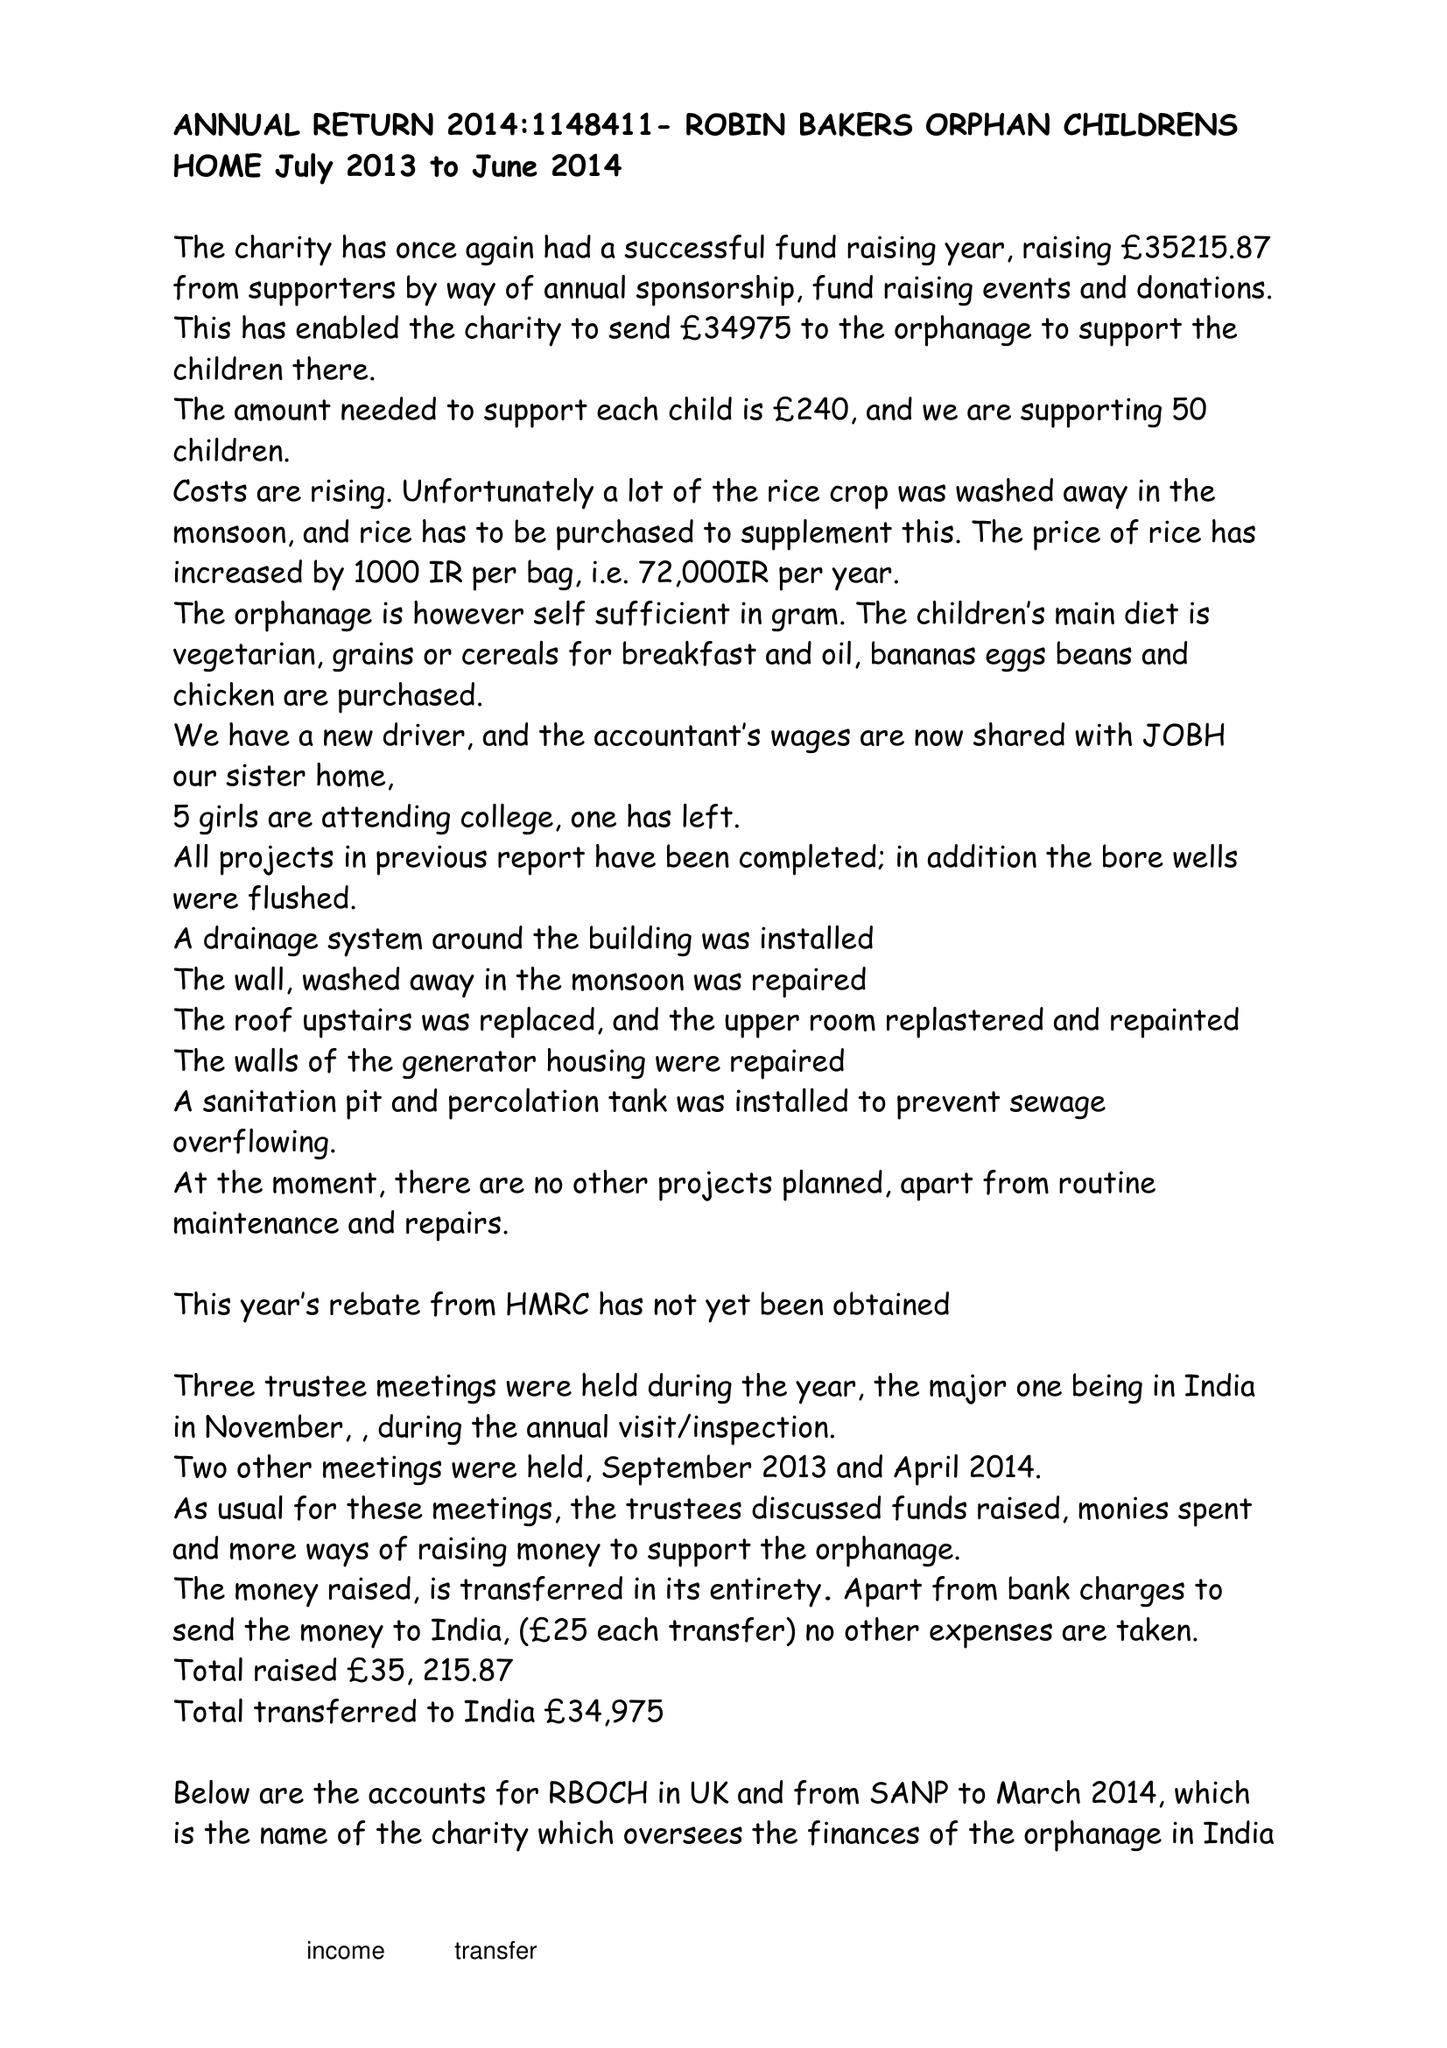What is the value for the income_annually_in_british_pounds?
Answer the question using a single word or phrase. 35216.00 